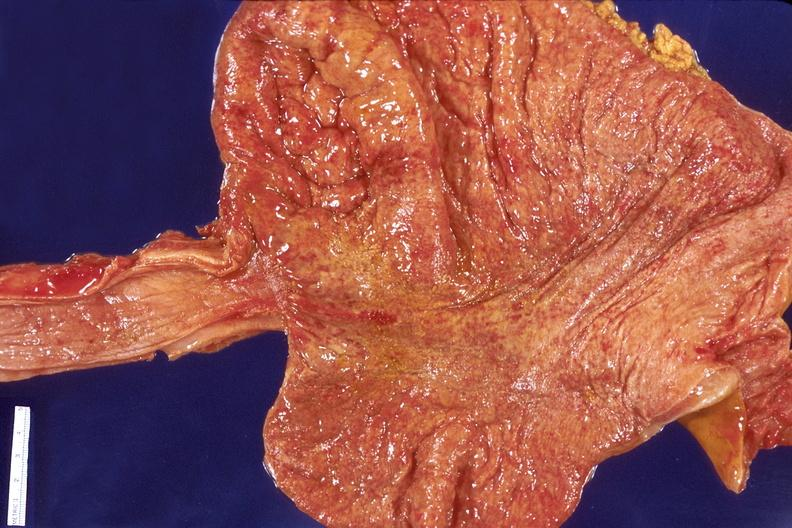s vasculature present?
Answer the question using a single word or phrase. No 